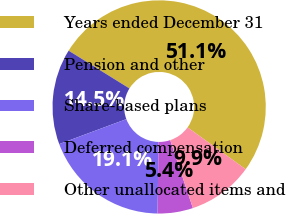Convert chart to OTSL. <chart><loc_0><loc_0><loc_500><loc_500><pie_chart><fcel>Years ended December 31<fcel>Pension and other<fcel>Share-based plans<fcel>Deferred compensation<fcel>Other unallocated items and<nl><fcel>51.08%<fcel>14.51%<fcel>19.09%<fcel>5.37%<fcel>9.94%<nl></chart> 